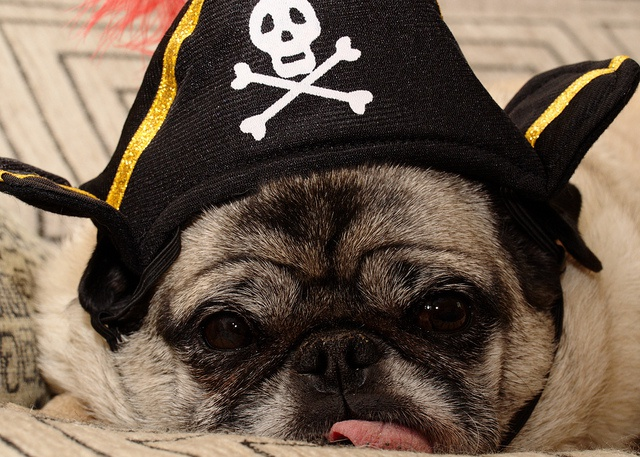Describe the objects in this image and their specific colors. I can see a dog in black, tan, and gray tones in this image. 